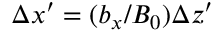<formula> <loc_0><loc_0><loc_500><loc_500>\Delta x ^ { \prime } = ( b _ { x } / B _ { 0 } ) \Delta z ^ { \prime }</formula> 